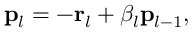Convert formula to latex. <formula><loc_0><loc_0><loc_500><loc_500>p _ { l } = - r _ { l } + \beta _ { l } p _ { l - 1 } ,</formula> 